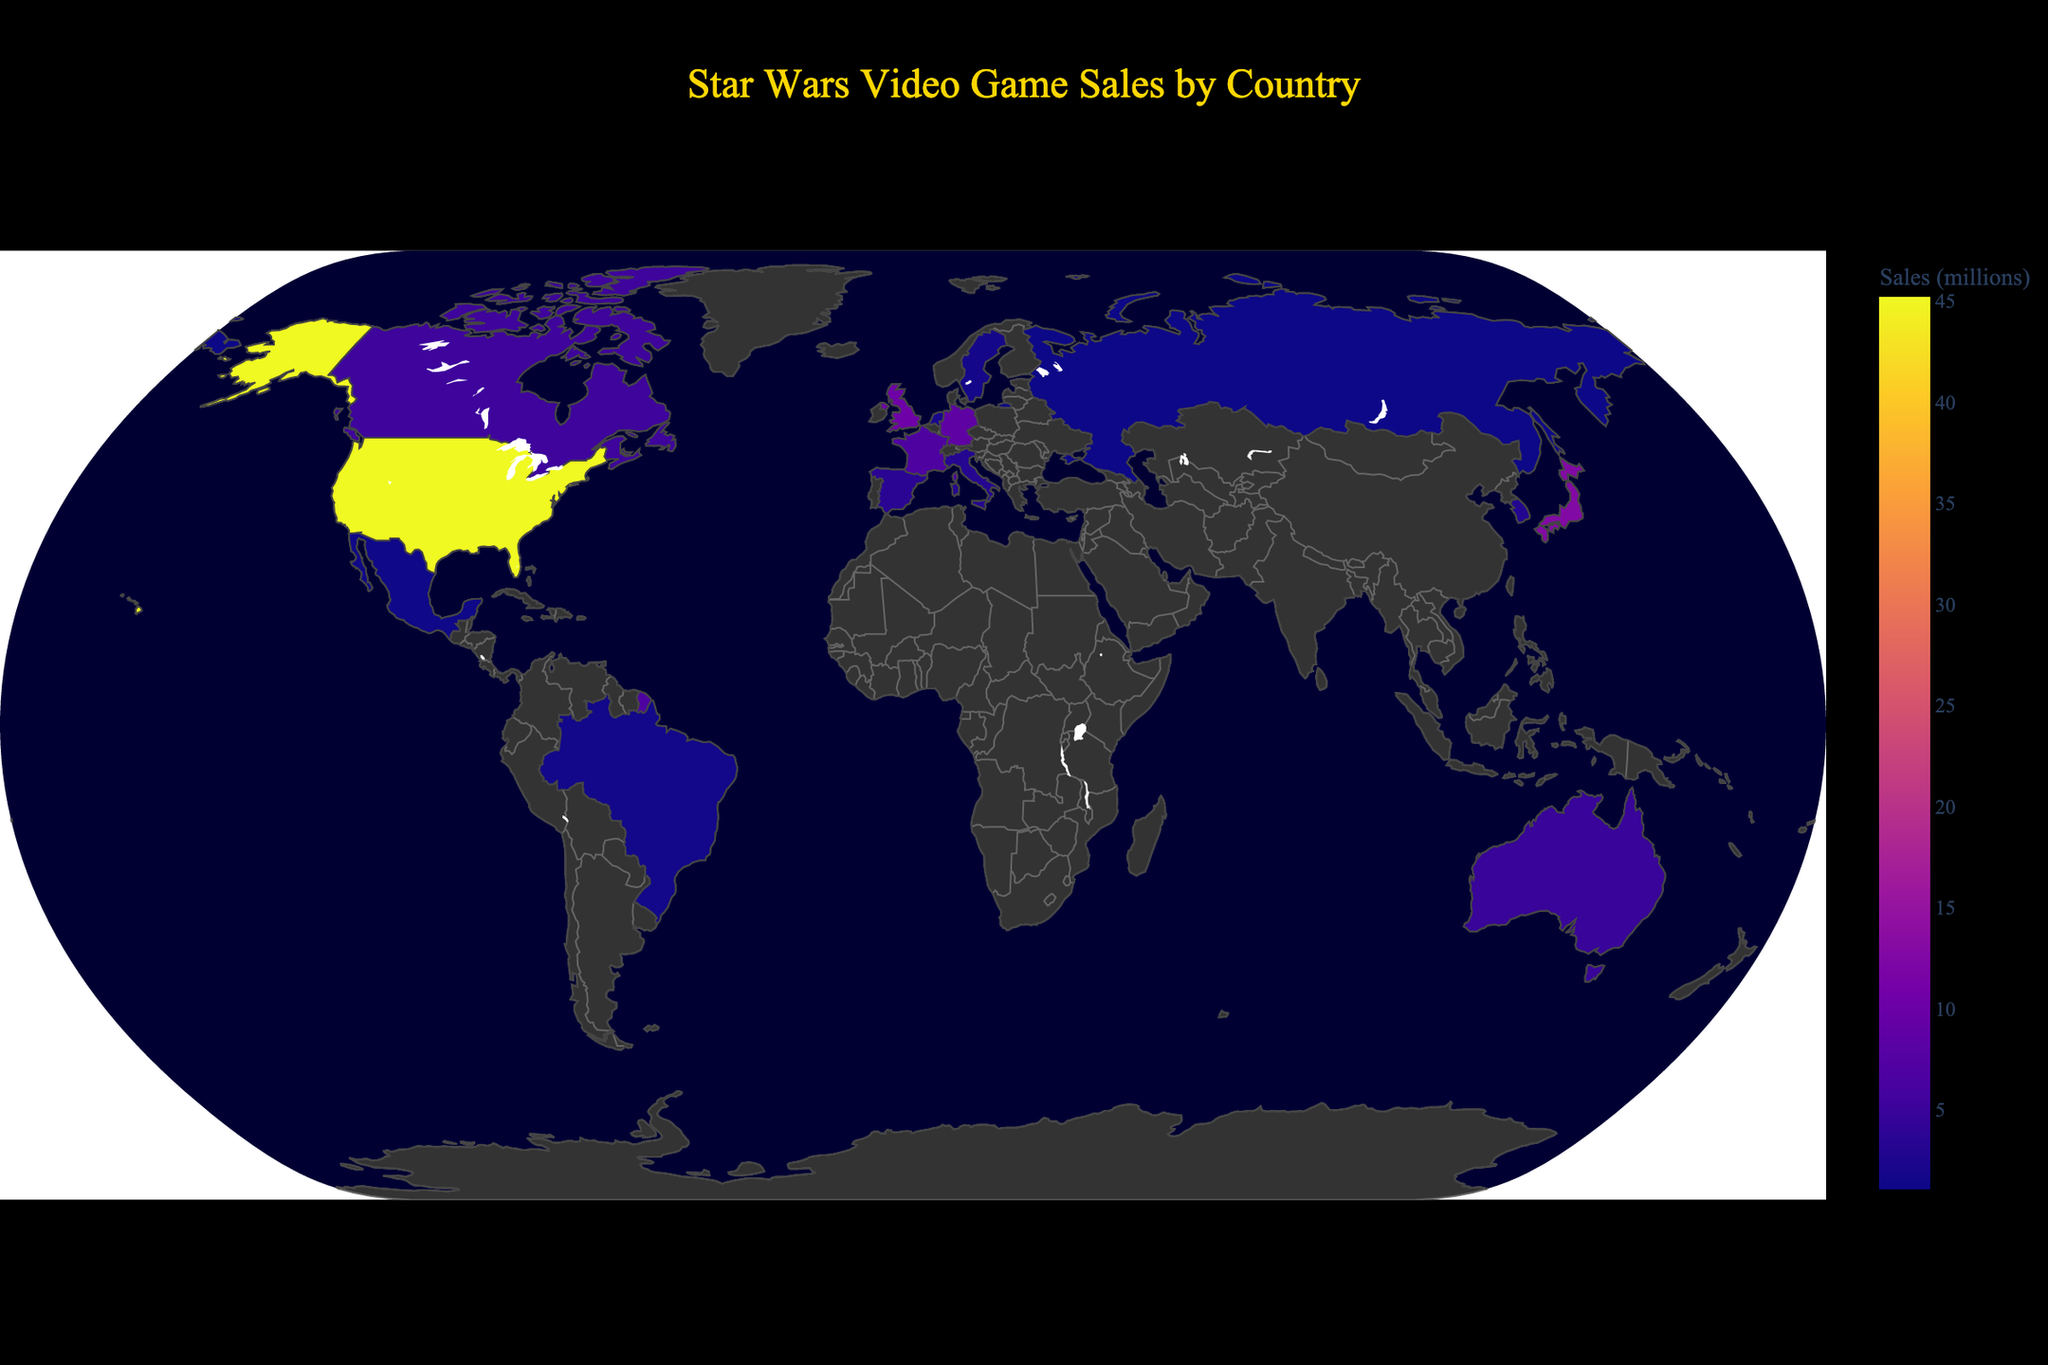What's the title of the plot? The title of the plot is displayed at the top center of the figure. It reads "Star Wars Video Game Sales by Country".
Answer: Star Wars Video Game Sales by Country Which country has the highest sales for Star Wars video games? The country with the highest sales is determined by looking at the shade with the strongest color intensity on the map, which corresponds to the United States.
Answer: United States What is the combined sales figure for Japan, the United Kingdom, and Germany? To find the combined sales for Japan, the United Kingdom, and Germany, sum the individual sales figures: 12.8 (Japan) + 10.5 (UK) + 8.7 (Germany) = 32.0
Answer: 32.0 Which country has lower sales, Italy or South Korea? By comparing the sales figures for Italy (3.2 million) and South Korea (2.9 million), we see that South Korea has lower sales.
Answer: South Korea What is the average sales figure for all the listed countries? To find the average sales figure, sum up the sales for all countries and then divide by the number of countries. The total sales are 117.7 million, and there are 15 countries: 117.7 / 15 = 7.85 million.
Answer: 7.85 How does the sales figure for France compare to that of Canada? The sales figure for France (6.9 million) is compared to that of Canada (5.3 million). France has higher sales than Canada.
Answer: France has higher sales than Canada Which countries have sales figures higher than 10 million? By scanning the figure, we identify countries with sales figures higher than 10 million: United States (45.2 million), Japan (12.8 million), and United Kingdom (10.5 million).
Answer: United States, Japan, United Kingdom How much more sales does the United States have compared to Italy? Subtract Italy's sales from the United States' sales: 45.2 (United States) - 3.2 (Italy) = 42.0. So, the United States has 42 million more sales than Italy.
Answer: 42.0 What are the total sales from countries in Europe listed in the plot? European countries listed are United Kingdom, Germany, France, Spain, Italy, Netherlands, and Sweden. Adding their sales: 10.5 + 8.7 + 6.9 + 3.6 + 3.2 + 2.1 + 1.8 = 36.8 million.
Answer: 36.8 Can you identify a country with noticeably low sales despite a large geographic size? Russia is a large geographic country with relatively low sales of 1.1 million.
Answer: Russia 